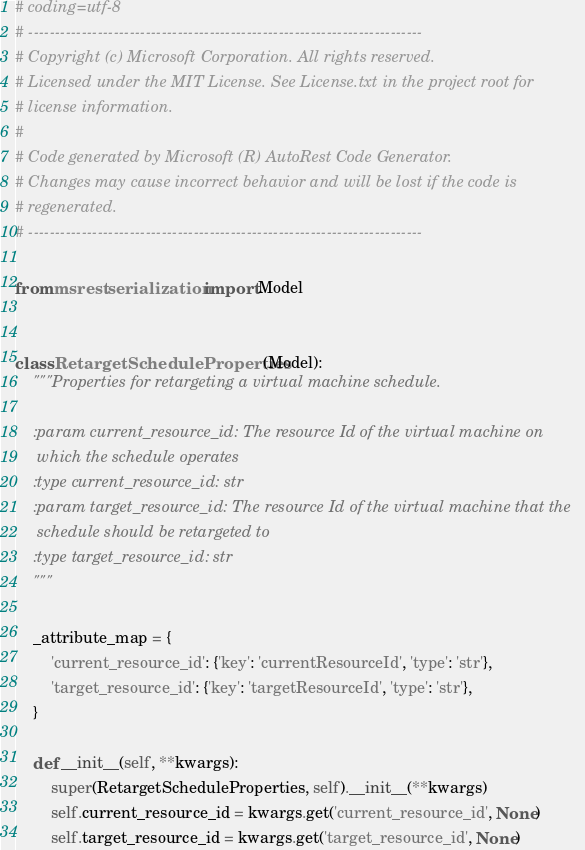<code> <loc_0><loc_0><loc_500><loc_500><_Python_># coding=utf-8
# --------------------------------------------------------------------------
# Copyright (c) Microsoft Corporation. All rights reserved.
# Licensed under the MIT License. See License.txt in the project root for
# license information.
#
# Code generated by Microsoft (R) AutoRest Code Generator.
# Changes may cause incorrect behavior and will be lost if the code is
# regenerated.
# --------------------------------------------------------------------------

from msrest.serialization import Model


class RetargetScheduleProperties(Model):
    """Properties for retargeting a virtual machine schedule.

    :param current_resource_id: The resource Id of the virtual machine on
     which the schedule operates
    :type current_resource_id: str
    :param target_resource_id: The resource Id of the virtual machine that the
     schedule should be retargeted to
    :type target_resource_id: str
    """

    _attribute_map = {
        'current_resource_id': {'key': 'currentResourceId', 'type': 'str'},
        'target_resource_id': {'key': 'targetResourceId', 'type': 'str'},
    }

    def __init__(self, **kwargs):
        super(RetargetScheduleProperties, self).__init__(**kwargs)
        self.current_resource_id = kwargs.get('current_resource_id', None)
        self.target_resource_id = kwargs.get('target_resource_id', None)
</code> 